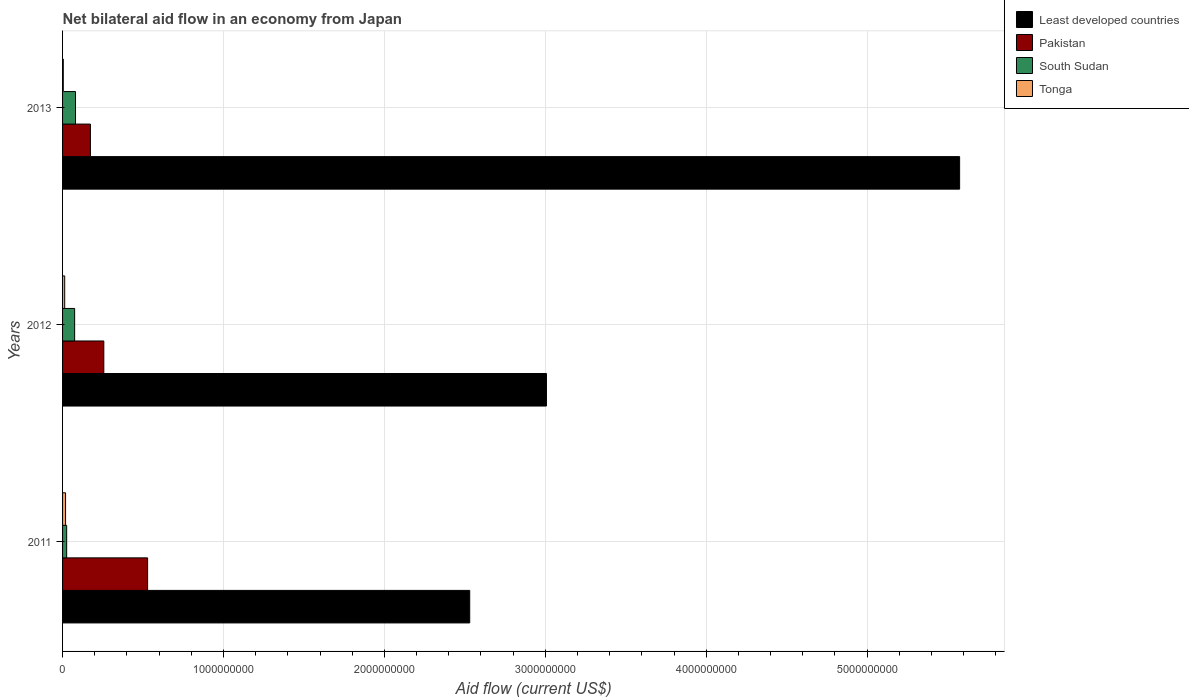How many different coloured bars are there?
Your answer should be compact. 4. How many groups of bars are there?
Keep it short and to the point. 3. Are the number of bars per tick equal to the number of legend labels?
Provide a succinct answer. Yes. Are the number of bars on each tick of the Y-axis equal?
Ensure brevity in your answer.  Yes. How many bars are there on the 1st tick from the top?
Your response must be concise. 4. What is the net bilateral aid flow in Tonga in 2013?
Your answer should be compact. 4.50e+06. Across all years, what is the maximum net bilateral aid flow in South Sudan?
Provide a short and direct response. 8.04e+07. Across all years, what is the minimum net bilateral aid flow in Pakistan?
Offer a very short reply. 1.73e+08. In which year was the net bilateral aid flow in Pakistan maximum?
Make the answer very short. 2011. What is the total net bilateral aid flow in Pakistan in the graph?
Ensure brevity in your answer.  9.58e+08. What is the difference between the net bilateral aid flow in Least developed countries in 2011 and that in 2012?
Make the answer very short. -4.77e+08. What is the difference between the net bilateral aid flow in Least developed countries in 2011 and the net bilateral aid flow in South Sudan in 2013?
Provide a short and direct response. 2.45e+09. What is the average net bilateral aid flow in Tonga per year?
Offer a very short reply. 1.21e+07. In the year 2013, what is the difference between the net bilateral aid flow in South Sudan and net bilateral aid flow in Pakistan?
Your response must be concise. -9.26e+07. What is the ratio of the net bilateral aid flow in South Sudan in 2012 to that in 2013?
Give a very brief answer. 0.93. Is the net bilateral aid flow in Least developed countries in 2011 less than that in 2013?
Your answer should be very brief. Yes. What is the difference between the highest and the second highest net bilateral aid flow in Tonga?
Keep it short and to the point. 5.31e+06. What is the difference between the highest and the lowest net bilateral aid flow in Pakistan?
Your answer should be compact. 3.56e+08. In how many years, is the net bilateral aid flow in Least developed countries greater than the average net bilateral aid flow in Least developed countries taken over all years?
Provide a succinct answer. 1. Is the sum of the net bilateral aid flow in Tonga in 2011 and 2013 greater than the maximum net bilateral aid flow in South Sudan across all years?
Offer a terse response. No. What does the 3rd bar from the top in 2011 represents?
Give a very brief answer. Pakistan. What does the 4th bar from the bottom in 2013 represents?
Your response must be concise. Tonga. How many bars are there?
Make the answer very short. 12. How many years are there in the graph?
Make the answer very short. 3. What is the difference between two consecutive major ticks on the X-axis?
Keep it short and to the point. 1.00e+09. Does the graph contain any zero values?
Keep it short and to the point. No. How many legend labels are there?
Keep it short and to the point. 4. How are the legend labels stacked?
Keep it short and to the point. Vertical. What is the title of the graph?
Provide a short and direct response. Net bilateral aid flow in an economy from Japan. Does "Italy" appear as one of the legend labels in the graph?
Ensure brevity in your answer.  No. What is the label or title of the Y-axis?
Your response must be concise. Years. What is the Aid flow (current US$) in Least developed countries in 2011?
Give a very brief answer. 2.53e+09. What is the Aid flow (current US$) in Pakistan in 2011?
Make the answer very short. 5.28e+08. What is the Aid flow (current US$) of South Sudan in 2011?
Your answer should be compact. 2.56e+07. What is the Aid flow (current US$) in Tonga in 2011?
Offer a very short reply. 1.86e+07. What is the Aid flow (current US$) of Least developed countries in 2012?
Provide a short and direct response. 3.01e+09. What is the Aid flow (current US$) of Pakistan in 2012?
Your answer should be compact. 2.56e+08. What is the Aid flow (current US$) in South Sudan in 2012?
Give a very brief answer. 7.50e+07. What is the Aid flow (current US$) of Tonga in 2012?
Offer a very short reply. 1.33e+07. What is the Aid flow (current US$) in Least developed countries in 2013?
Provide a short and direct response. 5.57e+09. What is the Aid flow (current US$) of Pakistan in 2013?
Provide a short and direct response. 1.73e+08. What is the Aid flow (current US$) in South Sudan in 2013?
Ensure brevity in your answer.  8.04e+07. What is the Aid flow (current US$) of Tonga in 2013?
Provide a succinct answer. 4.50e+06. Across all years, what is the maximum Aid flow (current US$) in Least developed countries?
Your response must be concise. 5.57e+09. Across all years, what is the maximum Aid flow (current US$) of Pakistan?
Provide a succinct answer. 5.28e+08. Across all years, what is the maximum Aid flow (current US$) in South Sudan?
Provide a short and direct response. 8.04e+07. Across all years, what is the maximum Aid flow (current US$) in Tonga?
Your answer should be very brief. 1.86e+07. Across all years, what is the minimum Aid flow (current US$) in Least developed countries?
Your answer should be very brief. 2.53e+09. Across all years, what is the minimum Aid flow (current US$) in Pakistan?
Keep it short and to the point. 1.73e+08. Across all years, what is the minimum Aid flow (current US$) of South Sudan?
Your answer should be very brief. 2.56e+07. Across all years, what is the minimum Aid flow (current US$) of Tonga?
Your response must be concise. 4.50e+06. What is the total Aid flow (current US$) in Least developed countries in the graph?
Give a very brief answer. 1.11e+1. What is the total Aid flow (current US$) in Pakistan in the graph?
Offer a very short reply. 9.58e+08. What is the total Aid flow (current US$) in South Sudan in the graph?
Ensure brevity in your answer.  1.81e+08. What is the total Aid flow (current US$) in Tonga in the graph?
Make the answer very short. 3.64e+07. What is the difference between the Aid flow (current US$) of Least developed countries in 2011 and that in 2012?
Your response must be concise. -4.77e+08. What is the difference between the Aid flow (current US$) of Pakistan in 2011 and that in 2012?
Provide a short and direct response. 2.72e+08. What is the difference between the Aid flow (current US$) in South Sudan in 2011 and that in 2012?
Your answer should be compact. -4.95e+07. What is the difference between the Aid flow (current US$) of Tonga in 2011 and that in 2012?
Give a very brief answer. 5.31e+06. What is the difference between the Aid flow (current US$) of Least developed countries in 2011 and that in 2013?
Keep it short and to the point. -3.04e+09. What is the difference between the Aid flow (current US$) of Pakistan in 2011 and that in 2013?
Provide a short and direct response. 3.56e+08. What is the difference between the Aid flow (current US$) in South Sudan in 2011 and that in 2013?
Provide a succinct answer. -5.48e+07. What is the difference between the Aid flow (current US$) of Tonga in 2011 and that in 2013?
Offer a very short reply. 1.41e+07. What is the difference between the Aid flow (current US$) of Least developed countries in 2012 and that in 2013?
Your answer should be very brief. -2.57e+09. What is the difference between the Aid flow (current US$) of Pakistan in 2012 and that in 2013?
Offer a terse response. 8.34e+07. What is the difference between the Aid flow (current US$) of South Sudan in 2012 and that in 2013?
Provide a succinct answer. -5.33e+06. What is the difference between the Aid flow (current US$) in Tonga in 2012 and that in 2013?
Your answer should be compact. 8.80e+06. What is the difference between the Aid flow (current US$) of Least developed countries in 2011 and the Aid flow (current US$) of Pakistan in 2012?
Give a very brief answer. 2.27e+09. What is the difference between the Aid flow (current US$) of Least developed countries in 2011 and the Aid flow (current US$) of South Sudan in 2012?
Provide a succinct answer. 2.46e+09. What is the difference between the Aid flow (current US$) in Least developed countries in 2011 and the Aid flow (current US$) in Tonga in 2012?
Your response must be concise. 2.52e+09. What is the difference between the Aid flow (current US$) of Pakistan in 2011 and the Aid flow (current US$) of South Sudan in 2012?
Offer a terse response. 4.53e+08. What is the difference between the Aid flow (current US$) of Pakistan in 2011 and the Aid flow (current US$) of Tonga in 2012?
Your answer should be very brief. 5.15e+08. What is the difference between the Aid flow (current US$) of South Sudan in 2011 and the Aid flow (current US$) of Tonga in 2012?
Ensure brevity in your answer.  1.23e+07. What is the difference between the Aid flow (current US$) of Least developed countries in 2011 and the Aid flow (current US$) of Pakistan in 2013?
Provide a short and direct response. 2.36e+09. What is the difference between the Aid flow (current US$) of Least developed countries in 2011 and the Aid flow (current US$) of South Sudan in 2013?
Offer a terse response. 2.45e+09. What is the difference between the Aid flow (current US$) of Least developed countries in 2011 and the Aid flow (current US$) of Tonga in 2013?
Offer a very short reply. 2.53e+09. What is the difference between the Aid flow (current US$) in Pakistan in 2011 and the Aid flow (current US$) in South Sudan in 2013?
Your response must be concise. 4.48e+08. What is the difference between the Aid flow (current US$) in Pakistan in 2011 and the Aid flow (current US$) in Tonga in 2013?
Your response must be concise. 5.24e+08. What is the difference between the Aid flow (current US$) of South Sudan in 2011 and the Aid flow (current US$) of Tonga in 2013?
Your answer should be compact. 2.11e+07. What is the difference between the Aid flow (current US$) of Least developed countries in 2012 and the Aid flow (current US$) of Pakistan in 2013?
Your answer should be very brief. 2.83e+09. What is the difference between the Aid flow (current US$) in Least developed countries in 2012 and the Aid flow (current US$) in South Sudan in 2013?
Give a very brief answer. 2.93e+09. What is the difference between the Aid flow (current US$) of Least developed countries in 2012 and the Aid flow (current US$) of Tonga in 2013?
Offer a terse response. 3.00e+09. What is the difference between the Aid flow (current US$) in Pakistan in 2012 and the Aid flow (current US$) in South Sudan in 2013?
Your response must be concise. 1.76e+08. What is the difference between the Aid flow (current US$) of Pakistan in 2012 and the Aid flow (current US$) of Tonga in 2013?
Offer a very short reply. 2.52e+08. What is the difference between the Aid flow (current US$) in South Sudan in 2012 and the Aid flow (current US$) in Tonga in 2013?
Offer a terse response. 7.05e+07. What is the average Aid flow (current US$) in Least developed countries per year?
Offer a terse response. 3.70e+09. What is the average Aid flow (current US$) in Pakistan per year?
Provide a short and direct response. 3.19e+08. What is the average Aid flow (current US$) in South Sudan per year?
Your answer should be compact. 6.03e+07. What is the average Aid flow (current US$) in Tonga per year?
Provide a succinct answer. 1.21e+07. In the year 2011, what is the difference between the Aid flow (current US$) in Least developed countries and Aid flow (current US$) in Pakistan?
Make the answer very short. 2.00e+09. In the year 2011, what is the difference between the Aid flow (current US$) of Least developed countries and Aid flow (current US$) of South Sudan?
Offer a terse response. 2.50e+09. In the year 2011, what is the difference between the Aid flow (current US$) in Least developed countries and Aid flow (current US$) in Tonga?
Your response must be concise. 2.51e+09. In the year 2011, what is the difference between the Aid flow (current US$) in Pakistan and Aid flow (current US$) in South Sudan?
Your answer should be compact. 5.03e+08. In the year 2011, what is the difference between the Aid flow (current US$) of Pakistan and Aid flow (current US$) of Tonga?
Your answer should be very brief. 5.10e+08. In the year 2011, what is the difference between the Aid flow (current US$) of South Sudan and Aid flow (current US$) of Tonga?
Keep it short and to the point. 6.95e+06. In the year 2012, what is the difference between the Aid flow (current US$) of Least developed countries and Aid flow (current US$) of Pakistan?
Keep it short and to the point. 2.75e+09. In the year 2012, what is the difference between the Aid flow (current US$) in Least developed countries and Aid flow (current US$) in South Sudan?
Make the answer very short. 2.93e+09. In the year 2012, what is the difference between the Aid flow (current US$) of Least developed countries and Aid flow (current US$) of Tonga?
Offer a very short reply. 2.99e+09. In the year 2012, what is the difference between the Aid flow (current US$) of Pakistan and Aid flow (current US$) of South Sudan?
Offer a very short reply. 1.81e+08. In the year 2012, what is the difference between the Aid flow (current US$) of Pakistan and Aid flow (current US$) of Tonga?
Keep it short and to the point. 2.43e+08. In the year 2012, what is the difference between the Aid flow (current US$) in South Sudan and Aid flow (current US$) in Tonga?
Make the answer very short. 6.17e+07. In the year 2013, what is the difference between the Aid flow (current US$) of Least developed countries and Aid flow (current US$) of Pakistan?
Provide a short and direct response. 5.40e+09. In the year 2013, what is the difference between the Aid flow (current US$) of Least developed countries and Aid flow (current US$) of South Sudan?
Your answer should be compact. 5.49e+09. In the year 2013, what is the difference between the Aid flow (current US$) of Least developed countries and Aid flow (current US$) of Tonga?
Offer a terse response. 5.57e+09. In the year 2013, what is the difference between the Aid flow (current US$) of Pakistan and Aid flow (current US$) of South Sudan?
Your answer should be compact. 9.26e+07. In the year 2013, what is the difference between the Aid flow (current US$) of Pakistan and Aid flow (current US$) of Tonga?
Make the answer very short. 1.68e+08. In the year 2013, what is the difference between the Aid flow (current US$) in South Sudan and Aid flow (current US$) in Tonga?
Give a very brief answer. 7.59e+07. What is the ratio of the Aid flow (current US$) in Least developed countries in 2011 to that in 2012?
Offer a terse response. 0.84. What is the ratio of the Aid flow (current US$) in Pakistan in 2011 to that in 2012?
Your response must be concise. 2.06. What is the ratio of the Aid flow (current US$) of South Sudan in 2011 to that in 2012?
Provide a succinct answer. 0.34. What is the ratio of the Aid flow (current US$) of Tonga in 2011 to that in 2012?
Ensure brevity in your answer.  1.4. What is the ratio of the Aid flow (current US$) of Least developed countries in 2011 to that in 2013?
Offer a terse response. 0.45. What is the ratio of the Aid flow (current US$) in Pakistan in 2011 to that in 2013?
Give a very brief answer. 3.06. What is the ratio of the Aid flow (current US$) in South Sudan in 2011 to that in 2013?
Your answer should be very brief. 0.32. What is the ratio of the Aid flow (current US$) in Tonga in 2011 to that in 2013?
Your response must be concise. 4.14. What is the ratio of the Aid flow (current US$) in Least developed countries in 2012 to that in 2013?
Offer a very short reply. 0.54. What is the ratio of the Aid flow (current US$) in Pakistan in 2012 to that in 2013?
Your response must be concise. 1.48. What is the ratio of the Aid flow (current US$) in South Sudan in 2012 to that in 2013?
Your answer should be very brief. 0.93. What is the ratio of the Aid flow (current US$) in Tonga in 2012 to that in 2013?
Offer a very short reply. 2.96. What is the difference between the highest and the second highest Aid flow (current US$) of Least developed countries?
Give a very brief answer. 2.57e+09. What is the difference between the highest and the second highest Aid flow (current US$) of Pakistan?
Keep it short and to the point. 2.72e+08. What is the difference between the highest and the second highest Aid flow (current US$) of South Sudan?
Your answer should be very brief. 5.33e+06. What is the difference between the highest and the second highest Aid flow (current US$) in Tonga?
Keep it short and to the point. 5.31e+06. What is the difference between the highest and the lowest Aid flow (current US$) of Least developed countries?
Ensure brevity in your answer.  3.04e+09. What is the difference between the highest and the lowest Aid flow (current US$) in Pakistan?
Provide a short and direct response. 3.56e+08. What is the difference between the highest and the lowest Aid flow (current US$) of South Sudan?
Offer a terse response. 5.48e+07. What is the difference between the highest and the lowest Aid flow (current US$) in Tonga?
Provide a succinct answer. 1.41e+07. 